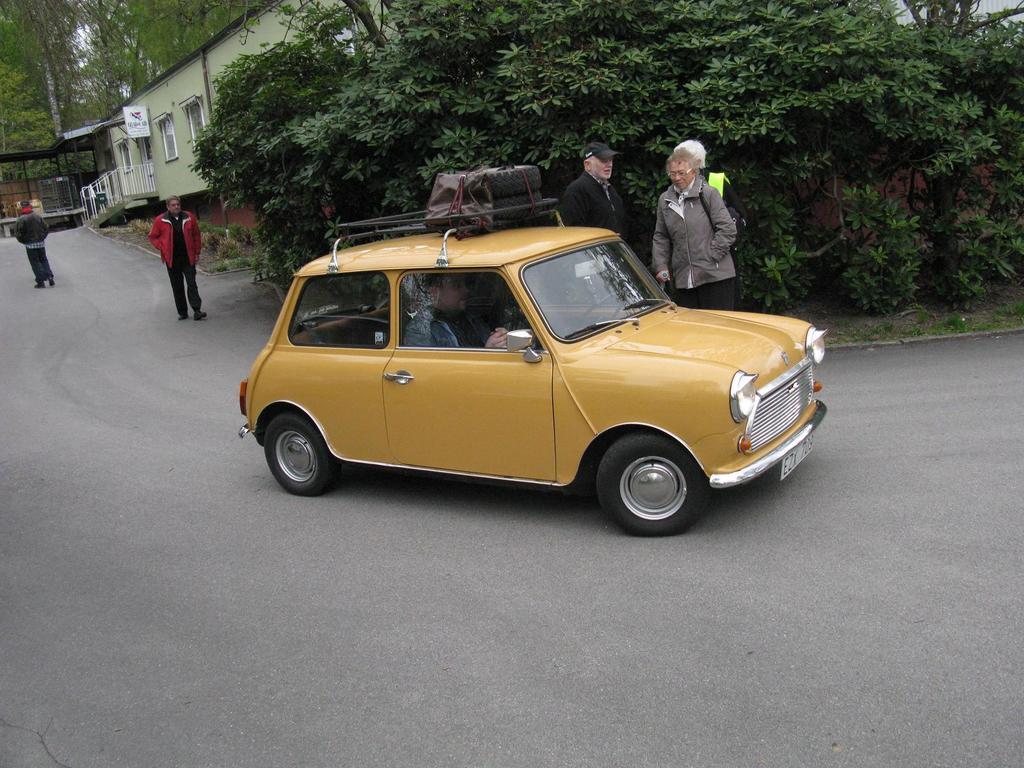Please provide a concise description of this image. In this image in the center there is one car and inside the car there is one man who is sitting and driving and on the background there are some trees and buildings are there. And some persons are walking and on the right side there are some persons who are standing. 